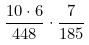<formula> <loc_0><loc_0><loc_500><loc_500>\frac { 1 0 \cdot 6 } { 4 4 8 } \cdot \frac { 7 } { 1 8 5 }</formula> 